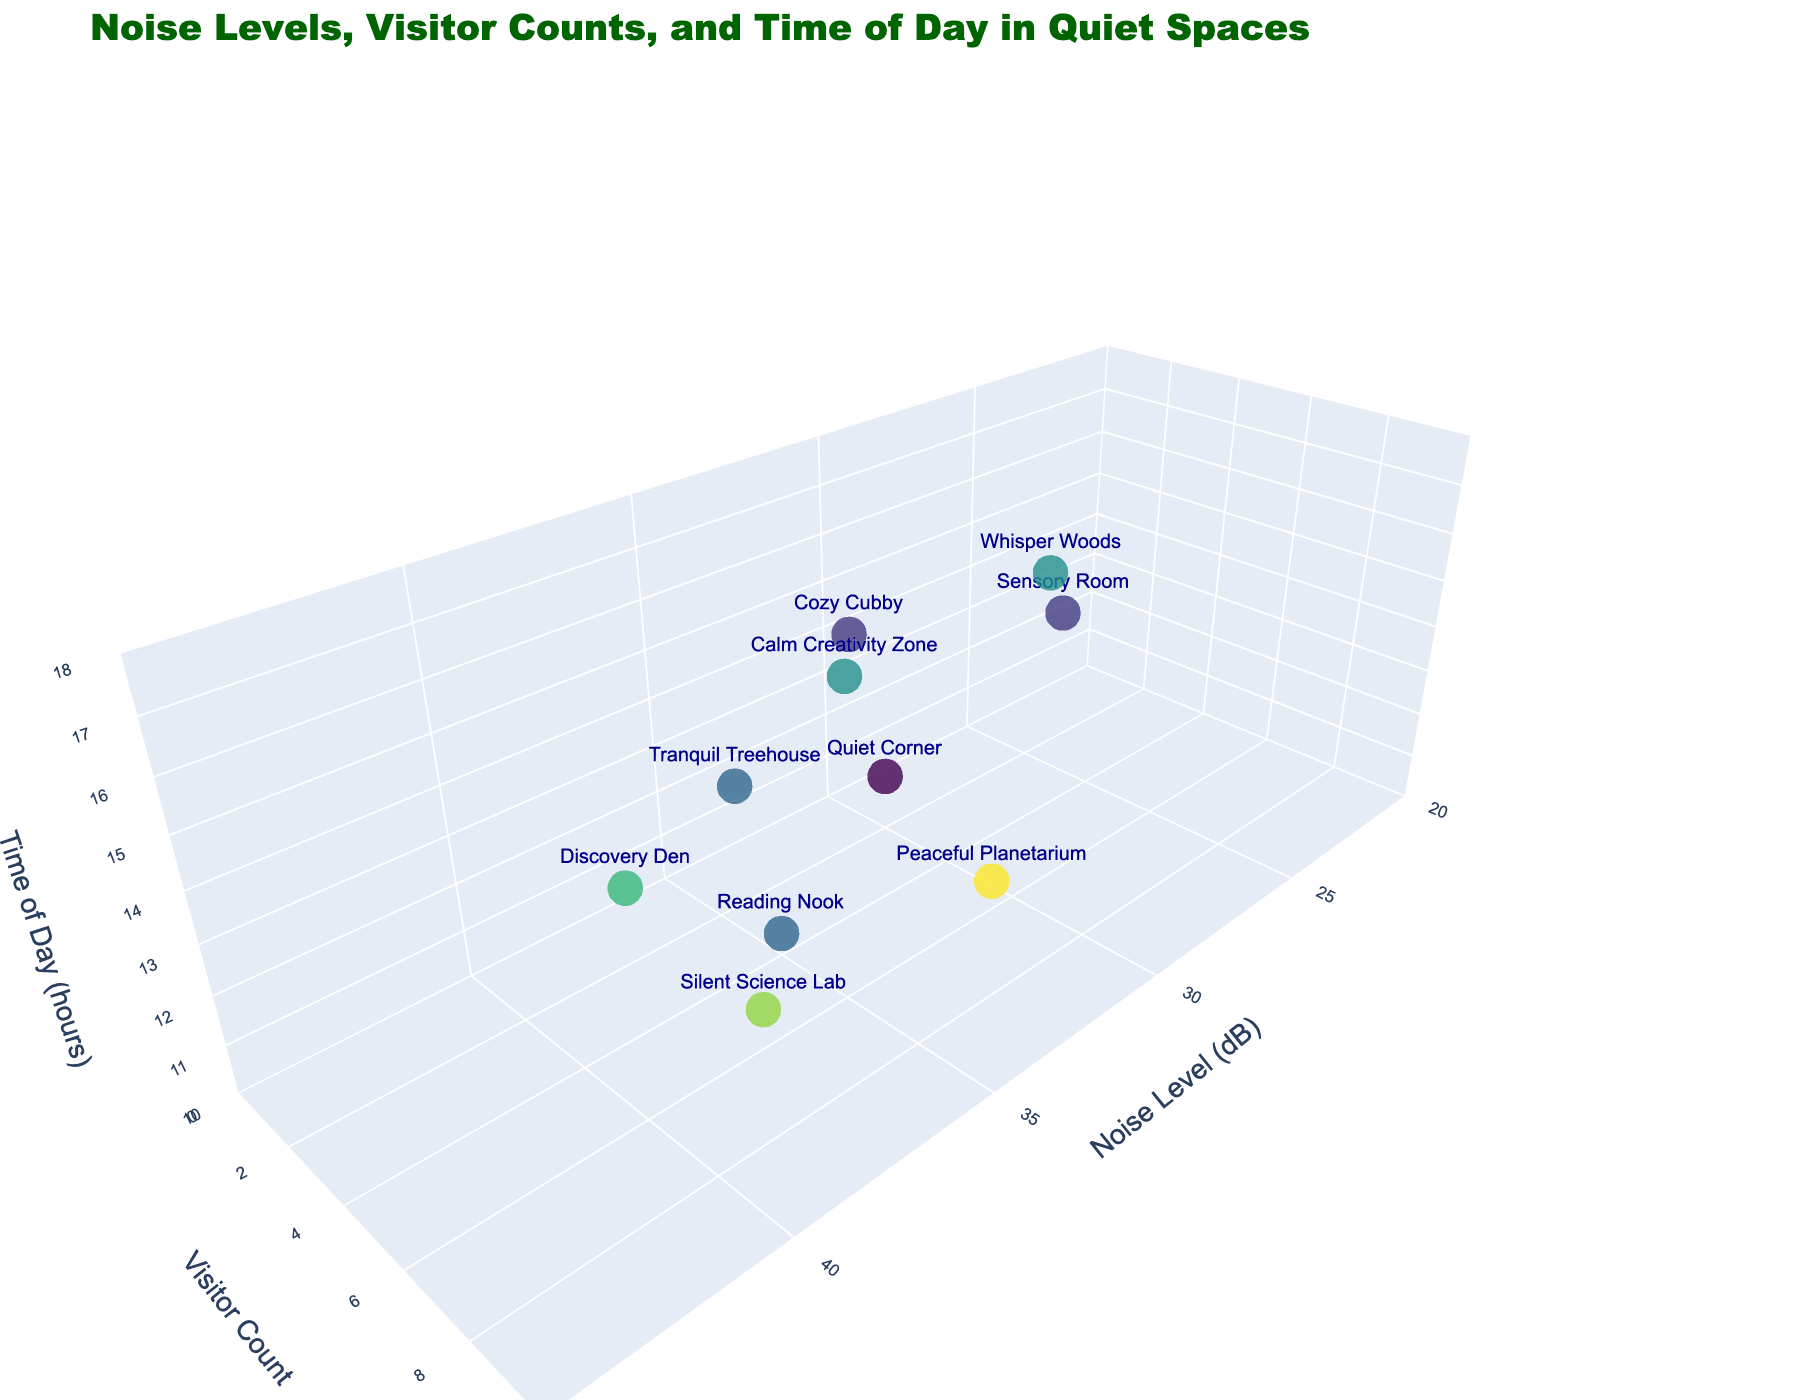what's the title of the figure? The title can be found at the top of the figure.
Answer: Noise Levels, Visitor Counts, and Time of Day in Quiet Spaces how many spaces have a visitor count of less than 5? The visitor count is along the vertical axis labeled "Visitor Count." Count how many data points fall under the value 5.
Answer: 5 which space has the highest noise level? Look at the horizontal axis labeled "Noise Level (dB)" and identify the data point with the highest value and its corresponding space name.
Answer: Discovery Den which space has the most visitors? Look at the vertical axis labeled "Visitor Count" and identify the data point with the highest value and its corresponding space name.
Answer: Peaceful Planetarium at what time of day is the Silent Science Lab the quietest? The time of day is represented on the z-axis. Locate the Silent Science Lab data point and check the time value associated with the Noisiness axis (x-axis).
Answer: 11:45 how many spaces have a noise level below 35 dB and more than 3 visitors? Check the data points where the noise level is below 35 dB on the x-axis and also see if the visitor count on the y-axis is greater than 3. Count these points.
Answer: 2 which space has the lowest noise level and what is it? Look at the horizontal axis for the lowest noise level and identify the corresponding space.
Answer: Sensory Room, 25 dB 